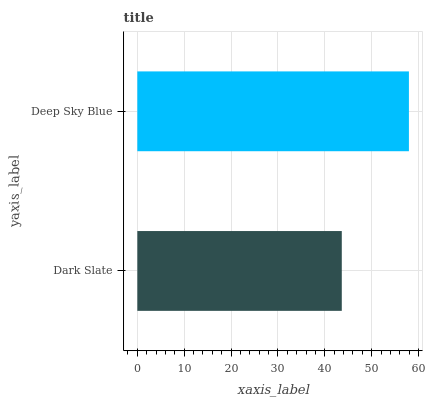Is Dark Slate the minimum?
Answer yes or no. Yes. Is Deep Sky Blue the maximum?
Answer yes or no. Yes. Is Deep Sky Blue the minimum?
Answer yes or no. No. Is Deep Sky Blue greater than Dark Slate?
Answer yes or no. Yes. Is Dark Slate less than Deep Sky Blue?
Answer yes or no. Yes. Is Dark Slate greater than Deep Sky Blue?
Answer yes or no. No. Is Deep Sky Blue less than Dark Slate?
Answer yes or no. No. Is Deep Sky Blue the high median?
Answer yes or no. Yes. Is Dark Slate the low median?
Answer yes or no. Yes. Is Dark Slate the high median?
Answer yes or no. No. Is Deep Sky Blue the low median?
Answer yes or no. No. 